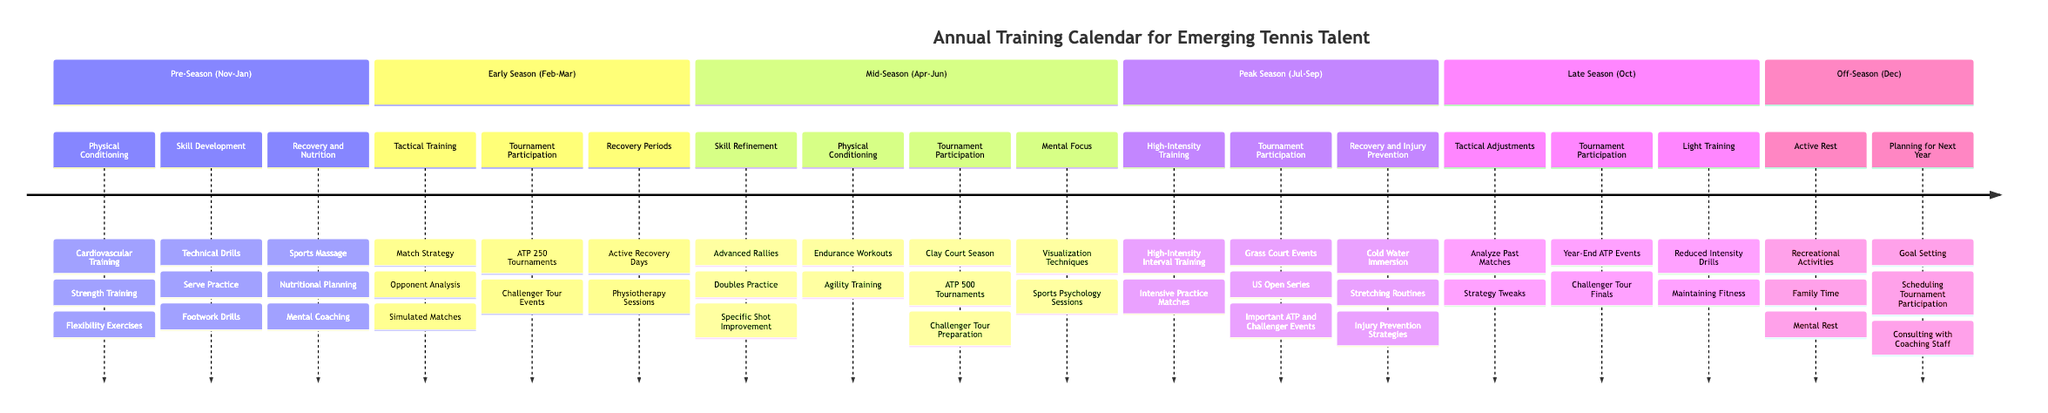What are the key focuses during the Peak Season? The Peak Season includes High-Intensity Training, Tournament Participation, and Recovery and Injury Prevention. This means that both skill enhancement and physical well-being are prioritized during this time.
Answer: High-Intensity Training, Tournament Participation, Recovery and Injury Prevention How many phases are there in the Annual Training Calendar? The Annual Training Calendar has six distinct phases: Pre-Season, Early Season, Mid-Season, Peak Season, Late Season, and Off-Season. Each phase covers different aspects of training and competition for emerging talent.
Answer: 6 During which phase are players expected to analyze their past matches? Players are expected to analyze their past matches during the Late Season, which focuses on Tactical Adjustments as part of their ongoing development.
Answer: Late Season What type of training occurs specifically in the Mid-Season? The Mid-Season includes Skill Refinement, Physical Conditioning, Mental Focus, and Tournament Participation. This indicates a focus on enhancing both technical skills and physical fitness as well as mental preparedness.
Answer: Skill Refinement, Physical Conditioning, Mental Focus, Tournament Participation What is included under Recovery and Nutrition in the Pre-Season? Under Recovery and Nutrition in the Pre-Season, there are Sports Massage, Nutritional Planning, and Mental Coaching, indicating a comprehensive approach to ensuring athletes are mentally and physically prepared.
Answer: Sports Massage, Nutritional Planning, Mental Coaching Which tournaments are scheduled for participation during the Early Season? During the Early Season, players participate in ATP 250 Tournaments and Challenger Tour Events, which serve as important competitive benchmarks as they start the season.
Answer: ATP 250 Tournaments, Challenger Tour Events What type of training occurs in the Off-Season? In the Off-Season, the focus is on Active Rest and Planning for Next Year, allowing players to recharge while also setting goals and preparing for the upcoming season.
Answer: Active Rest, Planning for Next Year How does the Mid-Season focus on mental strength? The Mid-Season includes Mental Focus sessions, such as Visualization Techniques and Sports Psychology Sessions, aimed at enhancing the mental resilience and strategic outlook of players.
Answer: Visualization Techniques, Sports Psychology Sessions 